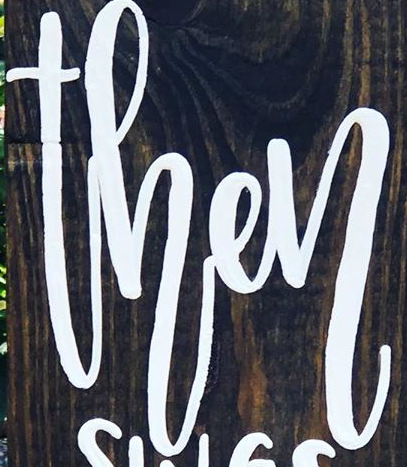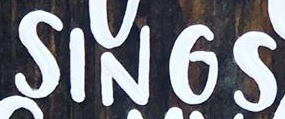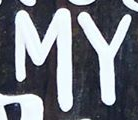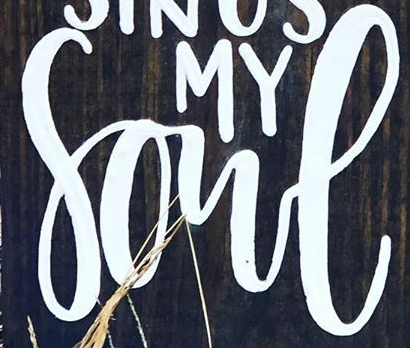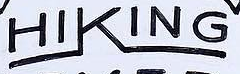Read the text from these images in sequence, separated by a semicolon. then; SINGS; MY; Sone; HIKING 